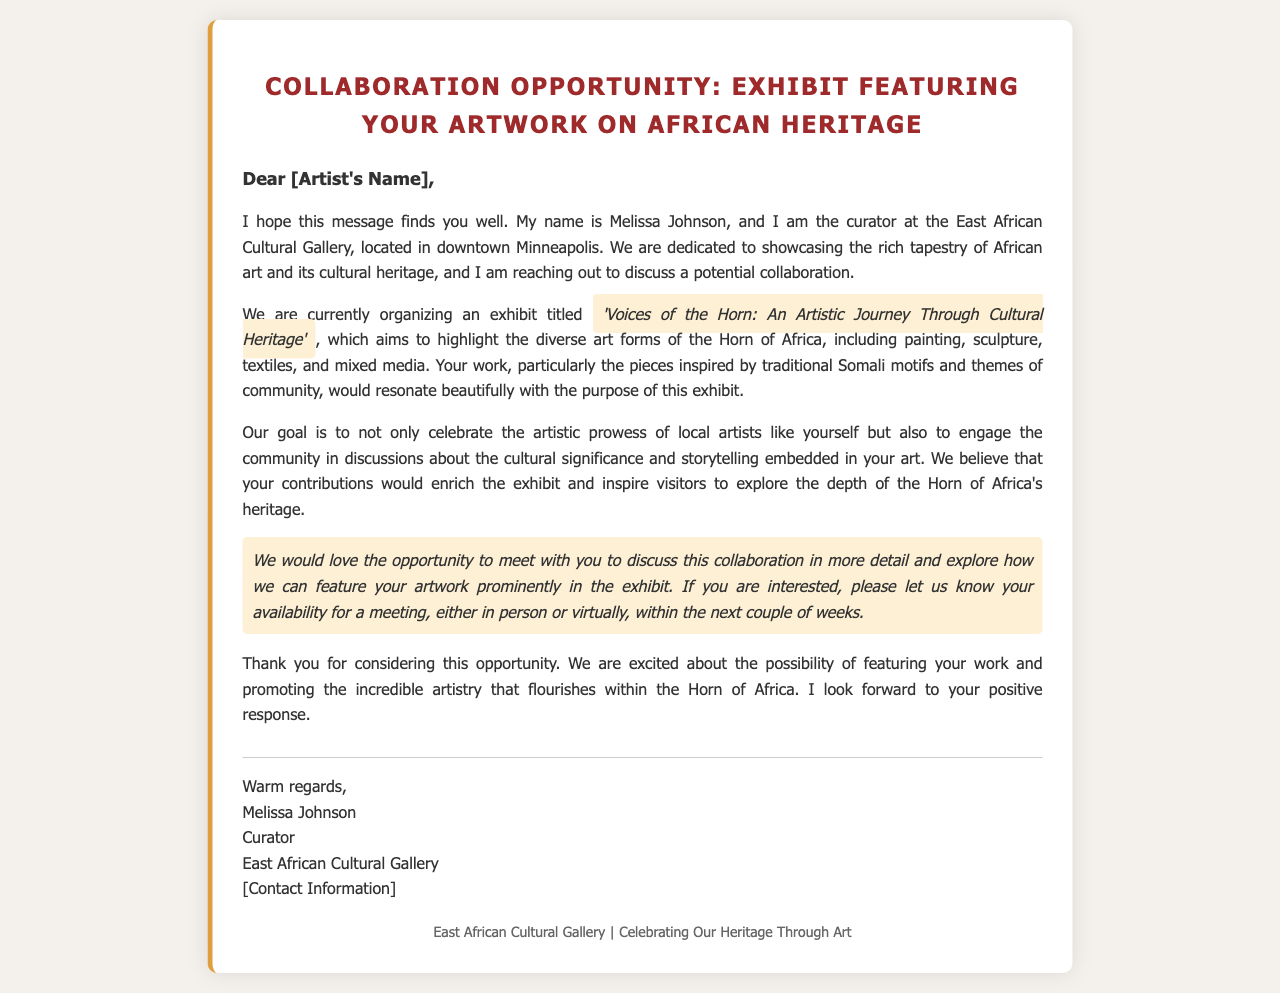What is the title of the exhibit? The title of the exhibit is mentioned in the document and is 'Voices of the Horn: An Artistic Journey Through Cultural Heritage'.
Answer: 'Voices of the Horn: An Artistic Journey Through Cultural Heritage' Who is the curator of the gallery? The document specifically introduces Melissa Johnson as the curator of the East African Cultural Gallery.
Answer: Melissa Johnson Where is the gallery located? The location of the East African Cultural Gallery is stated as downtown Minneapolis.
Answer: downtown Minneapolis What type of art forms will the exhibit highlight? The document lists various art forms including painting, sculpture, textiles, and mixed media that will be featured in the exhibit.
Answer: painting, sculpture, textiles, mixed media What is the goal of the exhibit? The document outlines that the goal of the exhibit is to celebrate artistic prowess and engage the community in discussions about cultural significance.
Answer: celebrate artistic prowess and engage the community What does the curator want to discuss? The curator expresses a desire to meet and discuss the collaboration in more detail regarding featuring the artist's work in the exhibit.
Answer: collaboration What is the theme of the artwork mentioned? The artwork mentioned is inspired by traditional Somali motifs and themes of community.
Answer: traditional Somali motifs and themes of community How is the invitation to collaborate communicated? The curator expresses eagerness for a meeting to discuss the collaboration, mentioning either in-person or virtual options.
Answer: meet with you to discuss this collaboration What is the closing sentiment of the mail? The closing sentiment involves excitement about the possibility of featuring the artist's work and promoting artistry in the Horn of Africa.
Answer: excited about the possibility of featuring your work 